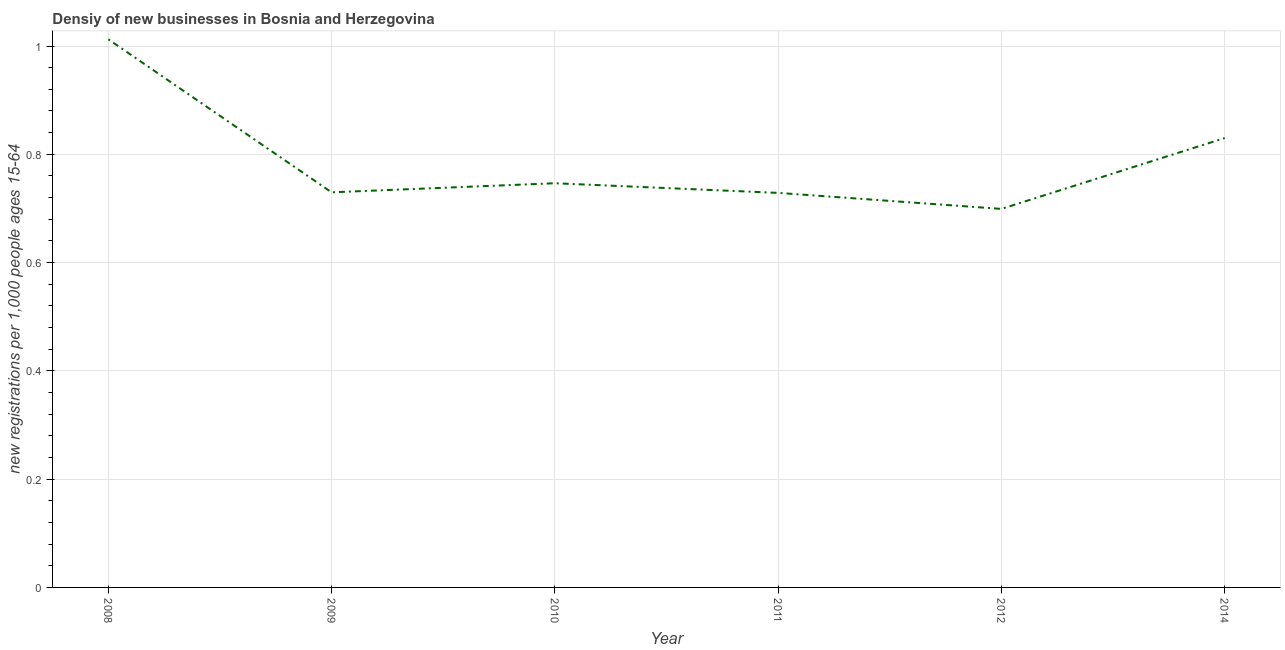What is the density of new business in 2014?
Your answer should be very brief. 0.83. Across all years, what is the maximum density of new business?
Your response must be concise. 1.01. Across all years, what is the minimum density of new business?
Give a very brief answer. 0.7. In which year was the density of new business maximum?
Give a very brief answer. 2008. In which year was the density of new business minimum?
Keep it short and to the point. 2012. What is the sum of the density of new business?
Your answer should be compact. 4.75. What is the difference between the density of new business in 2011 and 2012?
Keep it short and to the point. 0.03. What is the average density of new business per year?
Provide a short and direct response. 0.79. What is the median density of new business?
Provide a short and direct response. 0.74. Do a majority of the years between 2011 and 2012 (inclusive) have density of new business greater than 0.68 ?
Provide a succinct answer. Yes. What is the ratio of the density of new business in 2011 to that in 2012?
Provide a succinct answer. 1.04. Is the density of new business in 2008 less than that in 2014?
Provide a succinct answer. No. What is the difference between the highest and the second highest density of new business?
Give a very brief answer. 0.18. Is the sum of the density of new business in 2009 and 2014 greater than the maximum density of new business across all years?
Keep it short and to the point. Yes. What is the difference between the highest and the lowest density of new business?
Make the answer very short. 0.31. Does the density of new business monotonically increase over the years?
Give a very brief answer. No. How many lines are there?
Your response must be concise. 1. How many years are there in the graph?
Ensure brevity in your answer.  6. What is the difference between two consecutive major ticks on the Y-axis?
Provide a short and direct response. 0.2. Does the graph contain any zero values?
Give a very brief answer. No. Does the graph contain grids?
Provide a short and direct response. Yes. What is the title of the graph?
Offer a very short reply. Densiy of new businesses in Bosnia and Herzegovina. What is the label or title of the X-axis?
Keep it short and to the point. Year. What is the label or title of the Y-axis?
Provide a short and direct response. New registrations per 1,0 people ages 15-64. What is the new registrations per 1,000 people ages 15-64 in 2008?
Your answer should be compact. 1.01. What is the new registrations per 1,000 people ages 15-64 of 2009?
Provide a short and direct response. 0.73. What is the new registrations per 1,000 people ages 15-64 in 2010?
Give a very brief answer. 0.75. What is the new registrations per 1,000 people ages 15-64 in 2011?
Your answer should be very brief. 0.73. What is the new registrations per 1,000 people ages 15-64 in 2012?
Give a very brief answer. 0.7. What is the new registrations per 1,000 people ages 15-64 of 2014?
Keep it short and to the point. 0.83. What is the difference between the new registrations per 1,000 people ages 15-64 in 2008 and 2009?
Provide a short and direct response. 0.28. What is the difference between the new registrations per 1,000 people ages 15-64 in 2008 and 2010?
Your answer should be very brief. 0.27. What is the difference between the new registrations per 1,000 people ages 15-64 in 2008 and 2011?
Your answer should be compact. 0.28. What is the difference between the new registrations per 1,000 people ages 15-64 in 2008 and 2012?
Offer a very short reply. 0.31. What is the difference between the new registrations per 1,000 people ages 15-64 in 2008 and 2014?
Your response must be concise. 0.18. What is the difference between the new registrations per 1,000 people ages 15-64 in 2009 and 2010?
Provide a succinct answer. -0.02. What is the difference between the new registrations per 1,000 people ages 15-64 in 2009 and 2011?
Offer a very short reply. 0. What is the difference between the new registrations per 1,000 people ages 15-64 in 2009 and 2012?
Offer a terse response. 0.03. What is the difference between the new registrations per 1,000 people ages 15-64 in 2009 and 2014?
Provide a short and direct response. -0.1. What is the difference between the new registrations per 1,000 people ages 15-64 in 2010 and 2011?
Offer a very short reply. 0.02. What is the difference between the new registrations per 1,000 people ages 15-64 in 2010 and 2012?
Offer a very short reply. 0.05. What is the difference between the new registrations per 1,000 people ages 15-64 in 2010 and 2014?
Keep it short and to the point. -0.08. What is the difference between the new registrations per 1,000 people ages 15-64 in 2011 and 2012?
Your answer should be very brief. 0.03. What is the difference between the new registrations per 1,000 people ages 15-64 in 2011 and 2014?
Your response must be concise. -0.1. What is the difference between the new registrations per 1,000 people ages 15-64 in 2012 and 2014?
Offer a very short reply. -0.13. What is the ratio of the new registrations per 1,000 people ages 15-64 in 2008 to that in 2009?
Offer a terse response. 1.39. What is the ratio of the new registrations per 1,000 people ages 15-64 in 2008 to that in 2010?
Provide a succinct answer. 1.36. What is the ratio of the new registrations per 1,000 people ages 15-64 in 2008 to that in 2011?
Give a very brief answer. 1.39. What is the ratio of the new registrations per 1,000 people ages 15-64 in 2008 to that in 2012?
Offer a terse response. 1.45. What is the ratio of the new registrations per 1,000 people ages 15-64 in 2008 to that in 2014?
Your answer should be compact. 1.22. What is the ratio of the new registrations per 1,000 people ages 15-64 in 2009 to that in 2010?
Make the answer very short. 0.98. What is the ratio of the new registrations per 1,000 people ages 15-64 in 2009 to that in 2011?
Give a very brief answer. 1. What is the ratio of the new registrations per 1,000 people ages 15-64 in 2009 to that in 2012?
Give a very brief answer. 1.04. What is the ratio of the new registrations per 1,000 people ages 15-64 in 2009 to that in 2014?
Your answer should be very brief. 0.88. What is the ratio of the new registrations per 1,000 people ages 15-64 in 2010 to that in 2011?
Give a very brief answer. 1.02. What is the ratio of the new registrations per 1,000 people ages 15-64 in 2010 to that in 2012?
Offer a terse response. 1.07. What is the ratio of the new registrations per 1,000 people ages 15-64 in 2010 to that in 2014?
Provide a succinct answer. 0.9. What is the ratio of the new registrations per 1,000 people ages 15-64 in 2011 to that in 2012?
Offer a very short reply. 1.04. What is the ratio of the new registrations per 1,000 people ages 15-64 in 2011 to that in 2014?
Your answer should be very brief. 0.88. What is the ratio of the new registrations per 1,000 people ages 15-64 in 2012 to that in 2014?
Keep it short and to the point. 0.84. 